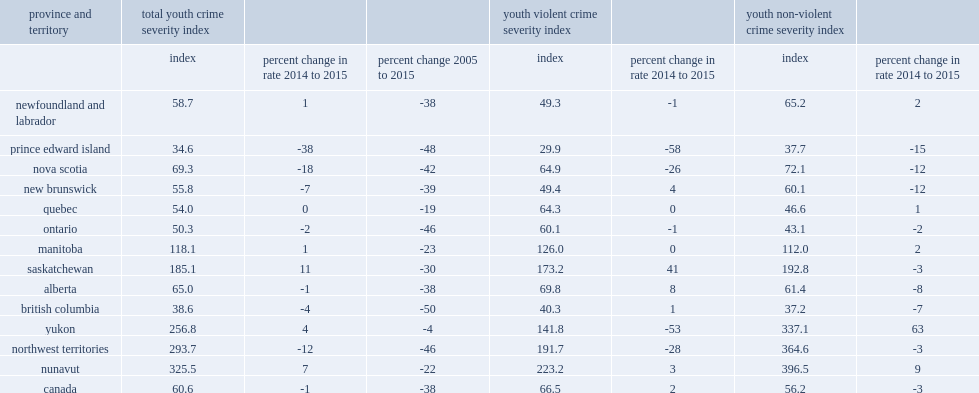What is the largest declines of total youth crime severity index reported in prince edward island in 2015? 38. What is the largest declines of total youth crime severity index reported in nova scotia in 2015? 18. What is the largest declines of total youth crime severity index reported in the northwest territories in 2015? 12. Other provinces and territories reported increases in their youth csis,what is the percentage of saskatchewan in 2015? 11.0. Other provinces and territories reported increases in their youth csis,what is the percentage of nunavut in 2015? 7.0. Other provinces and territories reported increases in their youth csis,what is the percentage of yukon in 2015? 4.0. What is the percentage of youth csi increased in manitoba in 2015? 1.0. What is the percentage of youth csi increased in newfoundland and labrador in 2015? 1.0. 